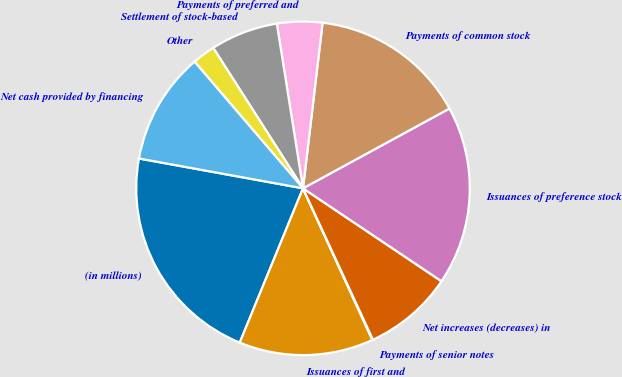<chart> <loc_0><loc_0><loc_500><loc_500><pie_chart><fcel>(in millions)<fcel>Issuances of first and<fcel>Payments of senior notes<fcel>Net increases (decreases) in<fcel>Issuances of preference stock<fcel>Payments of common stock<fcel>Payments of preferred and<fcel>Settlement of stock-based<fcel>Other<fcel>Net cash provided by financing<nl><fcel>21.66%<fcel>13.02%<fcel>0.06%<fcel>8.7%<fcel>17.34%<fcel>15.18%<fcel>4.38%<fcel>6.54%<fcel>2.22%<fcel>10.86%<nl></chart> 